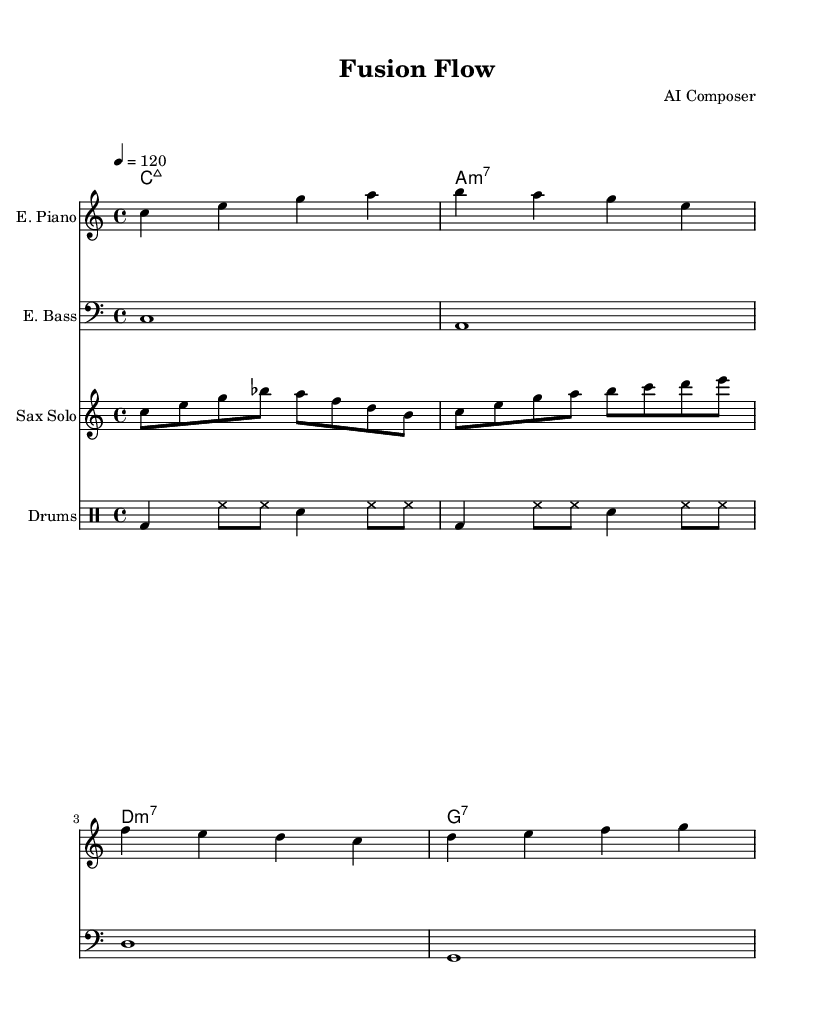What is the key signature of this music? The key signature is indicated at the beginning of the staff. It shows no sharps or flats, which corresponds to the key of C major.
Answer: C major What is the time signature of this music? The time signature is found at the beginning of the score, which indicates four beats per measure and a quarter note gets the beat, represented as 4/4.
Answer: 4/4 What is the tempo marking of this composition? The tempo marking, which denotes the speed of the music, appears at the beginning of the score and is indicated as quarter note equals 120 beats per minute.
Answer: 120 How many measures are in the electric piano part? By counting the vertical lines (bar lines) in the electric piano staff, there are four measures in total, as indicated by the structure of the music.
Answer: 4 Which instrument has a solo part in this piece? The solo part is specifically indicated in the score as belonging to the saxophone, which has its own staff dedicated to it.
Answer: Saxophone What is the first chord played in the chord progression? The chord names are listed above the music staff, and the first chord listed is C major seventh.
Answer: C major seventh What is the rhythm played by the drums in the first measure? Analyzing the drum patterns, the first measure consists of a bass drum and two hi-hat notes followed by a snare, which outlines the rhythm.
Answer: Bass drum and hi-hat 